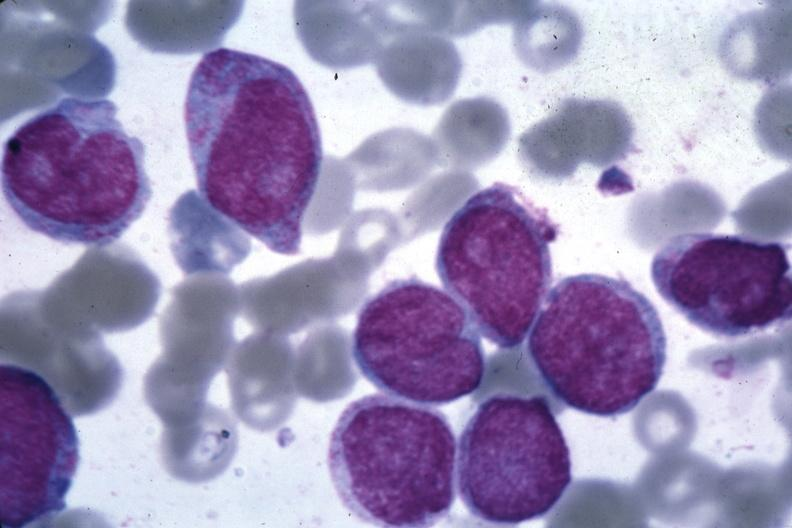s acute myelogenous leukemia present?
Answer the question using a single word or phrase. Yes 